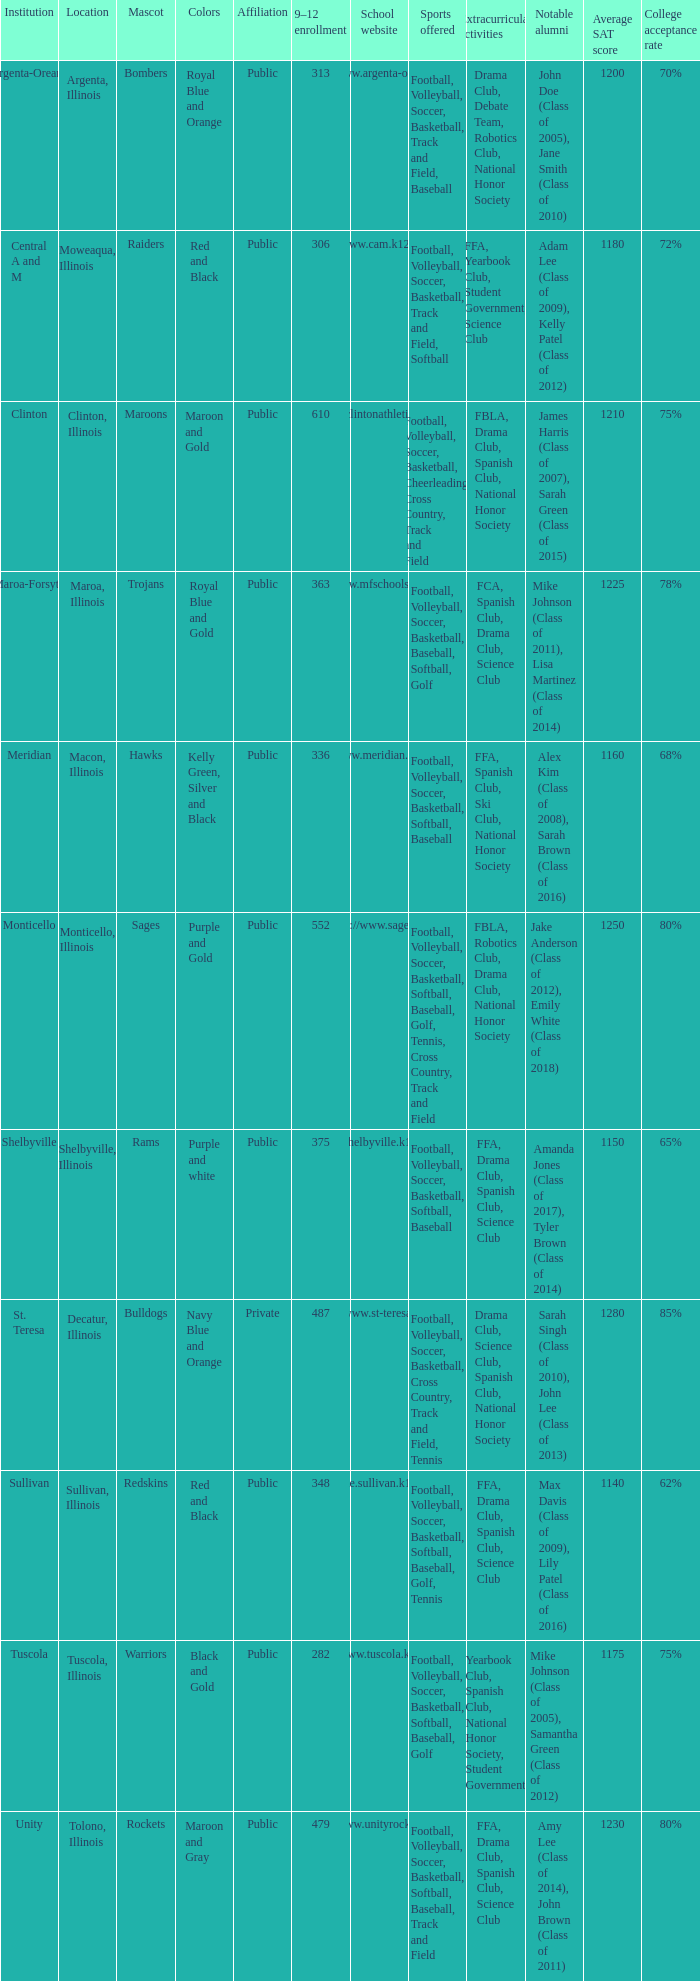What's the website of the school in Macon, Illinois? Http://www.meridian.k12.il.us/. 